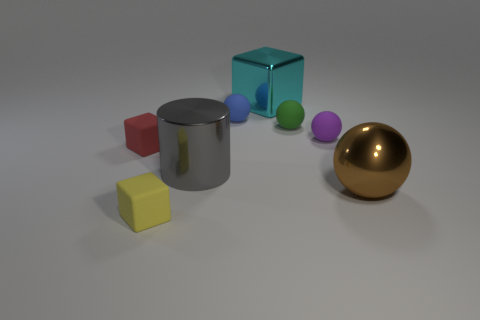What number of cubes are on the left side of the tiny yellow block?
Make the answer very short. 1. There is a small cube behind the tiny matte object in front of the brown shiny sphere; what is its material?
Keep it short and to the point. Rubber. There is a ball that is the same material as the cylinder; what is its size?
Keep it short and to the point. Large. There is a rubber block that is behind the large brown ball; what is its color?
Make the answer very short. Red. There is a big metal cylinder right of the rubber object that is on the left side of the yellow rubber object; is there a tiny purple matte thing that is to the right of it?
Offer a very short reply. Yes. Is the number of small yellow matte things left of the blue object greater than the number of tiny gray shiny balls?
Your response must be concise. Yes. There is a metallic thing that is right of the big cyan object; is it the same shape as the tiny green thing?
Give a very brief answer. Yes. How many objects are either green matte spheres or small rubber blocks that are behind the large gray shiny thing?
Make the answer very short. 2. What is the size of the rubber sphere that is both behind the tiny purple rubber thing and to the right of the tiny blue sphere?
Your answer should be very brief. Small. Is the number of large cyan things behind the blue thing greater than the number of big cyan shiny objects in front of the tiny green rubber object?
Your answer should be compact. Yes. 